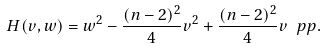Convert formula to latex. <formula><loc_0><loc_0><loc_500><loc_500>H ( v , w ) = w ^ { 2 } - \frac { ( n - 2 ) ^ { 2 } } { 4 } v ^ { 2 } + \frac { ( n - 2 ) ^ { 2 } } { 4 } v ^ { \ } p p .</formula> 